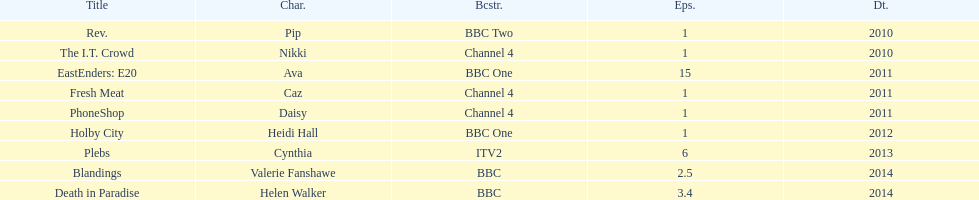How many titles have at least 5 episodes? 2. 